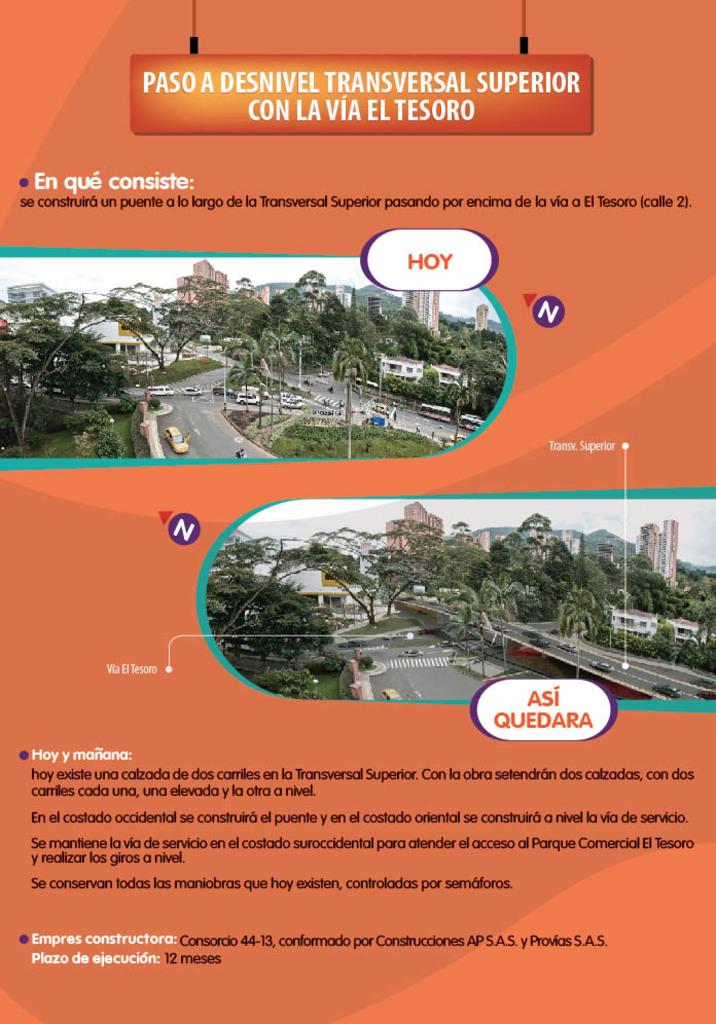What types of photos can be seen in the image? There are photos of buildings, trees, and vehicles on roads in the image. What is visible in the background of the image? The sky is visible in the image. What other objects can be seen in the image besides the photos? There are other objects in the image, but their specific details are not mentioned in the facts. Is there any text present on the image? Yes, there is something written on the image. What type of food is the cook preparing in the image? There is no cook or food preparation visible in the image; it only contains photos of buildings, trees, vehicles on roads, the sky, other objects, and something written on it. 